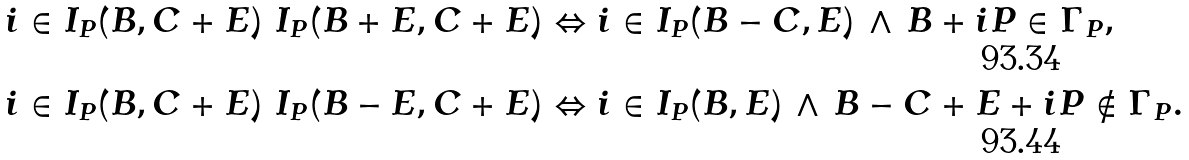Convert formula to latex. <formula><loc_0><loc_0><loc_500><loc_500>& i \in I _ { P } ( B , C + E ) \ I _ { P } ( B + E , C + E ) \Leftrightarrow i \in I _ { P } ( B - C , E ) \, \wedge \, B + i P \in \Gamma _ { P } , \\ & i \in I _ { P } ( B , C + E ) \ I _ { P } ( B - E , C + E ) \Leftrightarrow i \in I _ { P } ( B , E ) \, \wedge \, B - C + E + i P \not \in \Gamma _ { P } .</formula> 